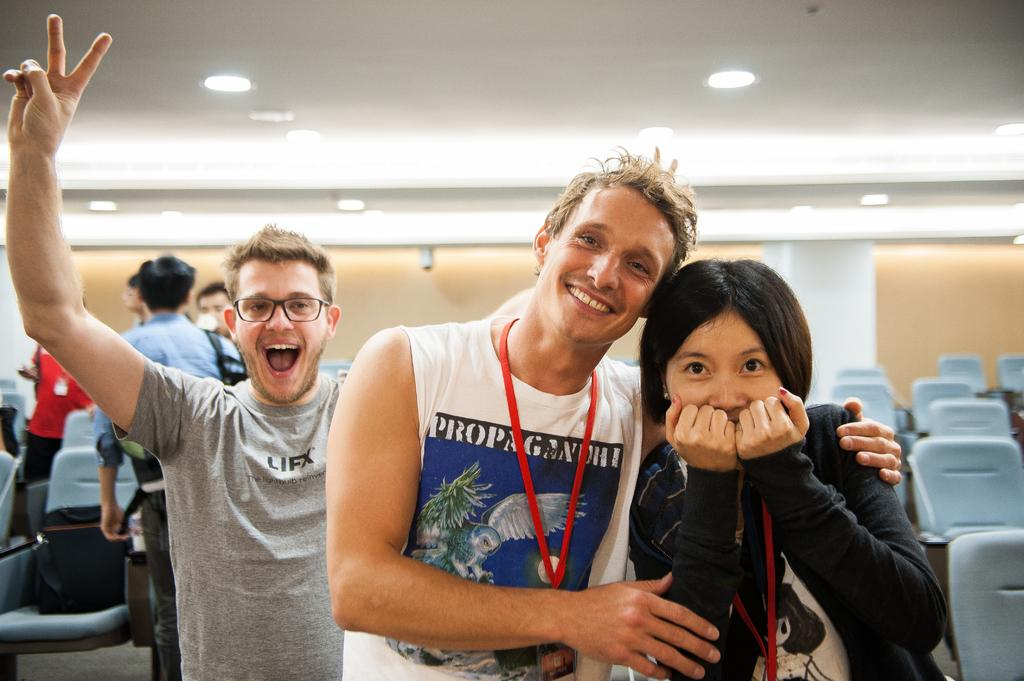What is happening in the image? There are people standing in the image. What are the people holding in their hands? The people are wearing ID cards in their hands. Can you see any skateboards being used by the people in the image? There is no mention of skateboards or any similar objects in the image. 